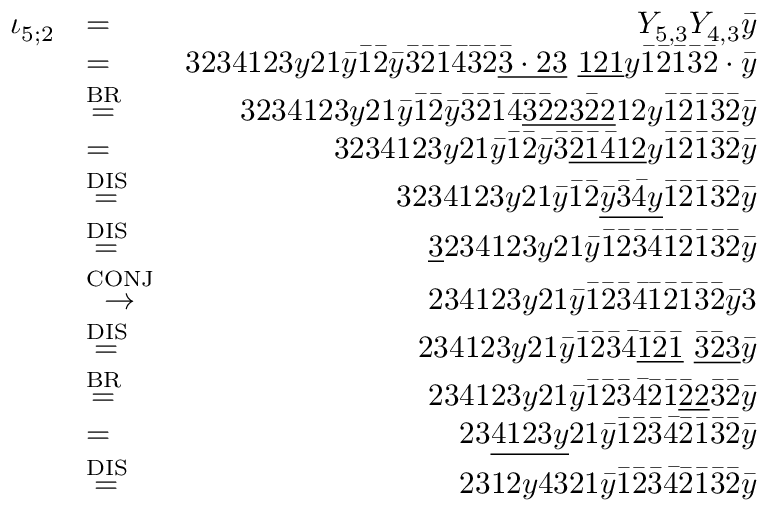<formula> <loc_0><loc_0><loc_500><loc_500>\begin{array} { r l r } { \iota _ { 5 ; 2 } } & { = } & { Y _ { 5 , 3 } Y _ { 4 , 3 } \bar { y } } \\ & { = } & { 3 2 3 4 1 2 3 y 2 1 \bar { y } \bar { 1 } \bar { 2 } \bar { y } \bar { 3 } \bar { 2 } \bar { 1 } \bar { 4 } \bar { 3 } \bar { 2 } \underline { { \bar { 3 } \cdot 2 3 } } \ \underline { 1 2 1 } y \bar { 1 } \bar { 2 } \bar { 1 } \bar { 3 } \bar { 2 } \cdot \bar { y } } \\ & { \stackrel { B R } { = } } & { 3 2 3 4 1 2 3 y 2 1 \bar { y } \bar { 1 } \bar { 2 } \bar { y } \bar { 3 } \bar { 2 } \bar { 1 } \bar { 4 } \underline { { \bar { 3 } \bar { 2 } 2 3 \bar { 2 } 2 } } 1 2 y \bar { 1 } \bar { 2 } \bar { 1 } \bar { 3 } \bar { 2 } \bar { y } } \\ & { = } & { 3 2 3 4 1 2 3 y 2 1 \bar { y } \bar { 1 } \bar { 2 } \bar { y } \bar { 3 } \underline { { \bar { 2 } \bar { 1 } \bar { 4 } 1 2 } } y \bar { 1 } \bar { 2 } \bar { 1 } \bar { 3 } \bar { 2 } \bar { y } } \\ & { \stackrel { D I S } { = } } & { 3 2 3 4 1 2 3 y 2 1 \bar { y } \bar { 1 } \bar { 2 } \underline { { \bar { y } \bar { 3 } \bar { 4 } y } } \bar { 1 } \bar { 2 } \bar { 1 } \bar { 3 } \bar { 2 } \bar { y } } \\ & { \stackrel { D I S } { = } } & { \underline { 3 } 2 3 4 1 2 3 y 2 1 \bar { y } \bar { 1 } \bar { 2 } \bar { 3 } \bar { 4 } \bar { 1 } \bar { 2 } \bar { 1 } \bar { 3 } \bar { 2 } \bar { y } } \\ & { \stackrel { C O N J } { \to } } & { 2 3 4 1 2 3 y 2 1 \bar { y } \bar { 1 } \bar { 2 } \bar { 3 } \bar { 4 } \bar { 1 } \bar { 2 } \bar { 1 } \bar { 3 } \bar { 2 } \bar { y } 3 } \\ & { \stackrel { D I S } { = } } & { 2 3 4 1 2 3 y 2 1 \bar { y } \bar { 1 } \bar { 2 } \bar { 3 } \bar { 4 } \underline { { \bar { 1 } \bar { 2 } \bar { 1 } } } \ \underline { { \bar { 3 } \bar { 2 } 3 } } \bar { y } } \\ & { \stackrel { B R } { = } } & { 2 3 4 1 2 3 y 2 1 \bar { y } \bar { 1 } \bar { 2 } \bar { 3 } \bar { 4 } \bar { 2 } \bar { 1 } \underline { { \bar { 2 } 2 } } \bar { 3 } \bar { 2 } \bar { y } } \\ & { = } & { 2 3 \underline { 4 1 2 3 y } 2 1 \bar { y } \bar { 1 } \bar { 2 } \bar { 3 } \bar { 4 } \bar { 2 } \bar { 1 } \bar { 3 } \bar { 2 } \bar { y } } \\ & { \stackrel { D I S } { = } } & { 2 3 1 2 y 4 3 2 1 \bar { y } \bar { 1 } \bar { 2 } \bar { 3 } \bar { 4 } \bar { 2 } \bar { 1 } \bar { 3 } \bar { 2 } \bar { y } } \end{array}</formula> 